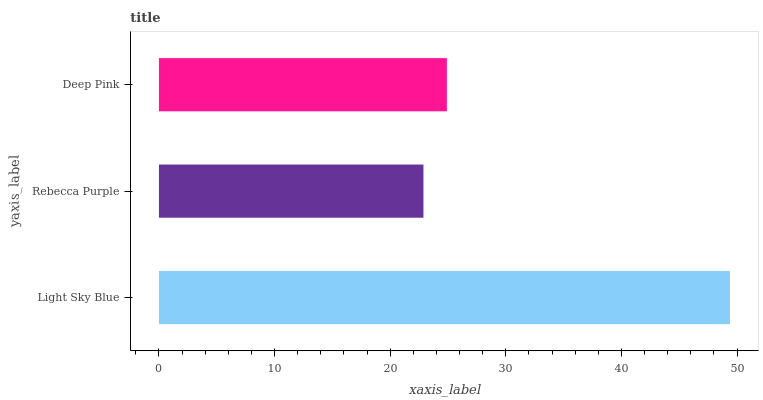Is Rebecca Purple the minimum?
Answer yes or no. Yes. Is Light Sky Blue the maximum?
Answer yes or no. Yes. Is Deep Pink the minimum?
Answer yes or no. No. Is Deep Pink the maximum?
Answer yes or no. No. Is Deep Pink greater than Rebecca Purple?
Answer yes or no. Yes. Is Rebecca Purple less than Deep Pink?
Answer yes or no. Yes. Is Rebecca Purple greater than Deep Pink?
Answer yes or no. No. Is Deep Pink less than Rebecca Purple?
Answer yes or no. No. Is Deep Pink the high median?
Answer yes or no. Yes. Is Deep Pink the low median?
Answer yes or no. Yes. Is Rebecca Purple the high median?
Answer yes or no. No. Is Rebecca Purple the low median?
Answer yes or no. No. 